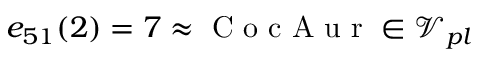<formula> <loc_0><loc_0><loc_500><loc_500>e _ { 5 1 } ( 2 ) = 7 \approx C o c A u r \in \mathcal { V } _ { p l }</formula> 